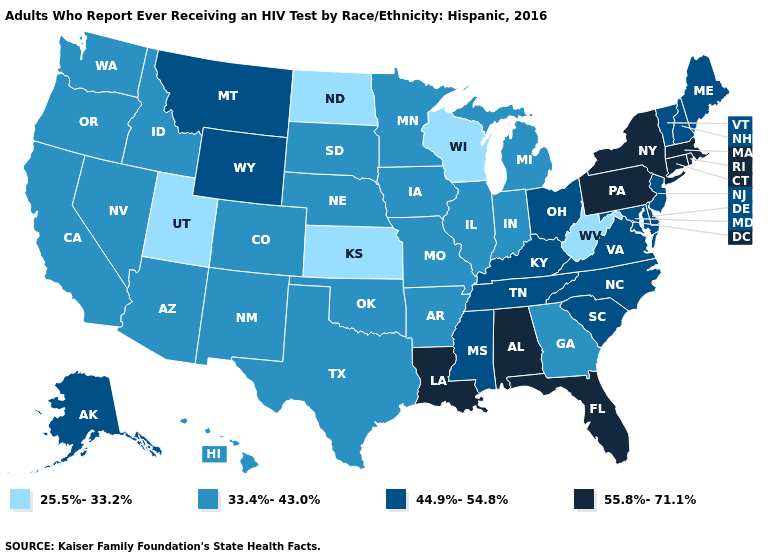Name the states that have a value in the range 44.9%-54.8%?
Quick response, please. Alaska, Delaware, Kentucky, Maine, Maryland, Mississippi, Montana, New Hampshire, New Jersey, North Carolina, Ohio, South Carolina, Tennessee, Vermont, Virginia, Wyoming. What is the value of South Dakota?
Answer briefly. 33.4%-43.0%. Does Ohio have the highest value in the MidWest?
Keep it brief. Yes. Does the first symbol in the legend represent the smallest category?
Quick response, please. Yes. Which states have the lowest value in the South?
Concise answer only. West Virginia. Which states have the highest value in the USA?
Write a very short answer. Alabama, Connecticut, Florida, Louisiana, Massachusetts, New York, Pennsylvania, Rhode Island. Which states have the lowest value in the USA?
Write a very short answer. Kansas, North Dakota, Utah, West Virginia, Wisconsin. Among the states that border Texas , does Louisiana have the highest value?
Concise answer only. Yes. What is the lowest value in the MidWest?
Answer briefly. 25.5%-33.2%. What is the highest value in the USA?
Be succinct. 55.8%-71.1%. What is the value of Nebraska?
Concise answer only. 33.4%-43.0%. What is the highest value in the USA?
Give a very brief answer. 55.8%-71.1%. What is the value of Kentucky?
Write a very short answer. 44.9%-54.8%. Which states have the lowest value in the USA?
Write a very short answer. Kansas, North Dakota, Utah, West Virginia, Wisconsin. 